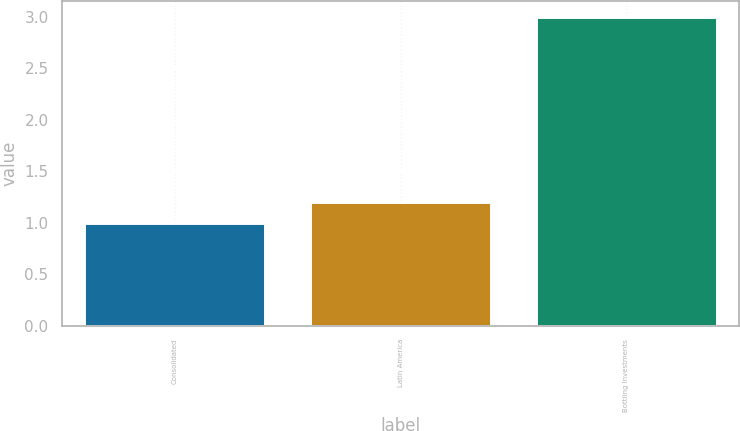Convert chart. <chart><loc_0><loc_0><loc_500><loc_500><bar_chart><fcel>Consolidated<fcel>Latin America<fcel>Bottling Investments<nl><fcel>1<fcel>1.2<fcel>3<nl></chart> 